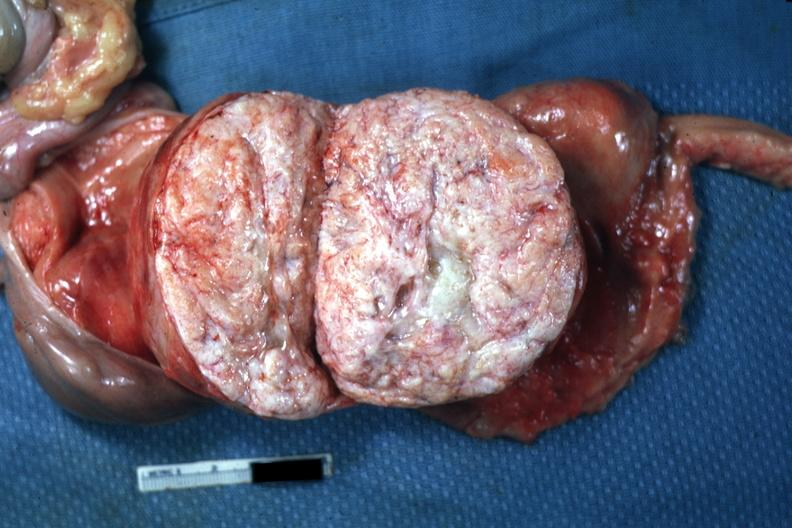what has this myoma been sliced can not readily see uterus itself myoma lesion is quite typical close-up photo?
Answer the question using a single word or phrase. Been open like book 